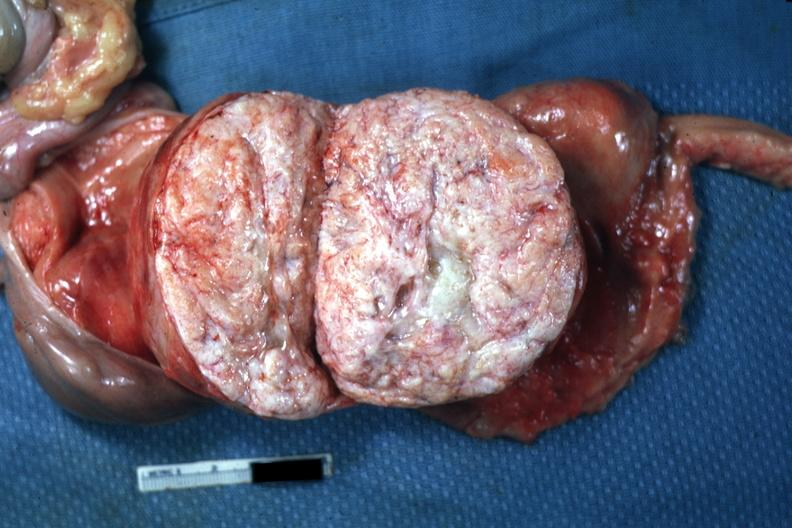what has this myoma been sliced can not readily see uterus itself myoma lesion is quite typical close-up photo?
Answer the question using a single word or phrase. Been open like book 